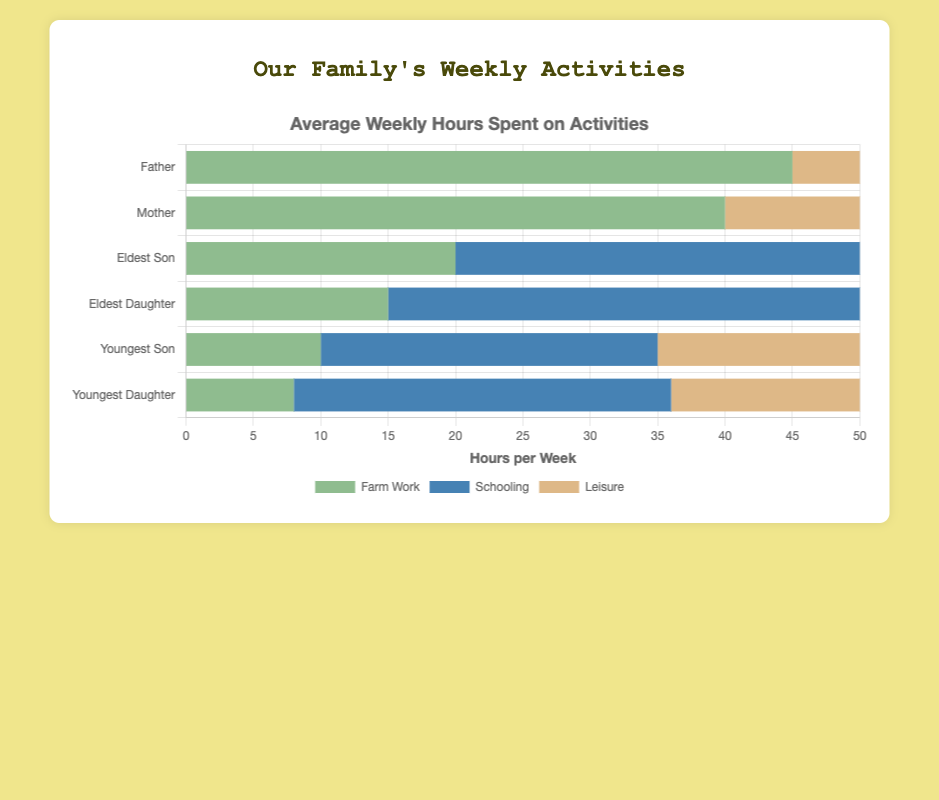What percentage of the father's weekly hours are spent on leisure? The total weekly hours for the father are 45 hours on farm work and 5 hours on leisure, making a total of 50 hours. The percentage spent on leisure is (5 / 50) * 100% = 10%.
Answer: 10% How many more hours does the mother spend on farm work than on leisure? The mother spends 40 hours on farm work and 10 hours on leisure. The difference is 40 - 10 = 30 hours.
Answer: 30 hours Who spends the most hours on schooling each week? By looking at the schooling hours for all family members, the eldest daughter spends the most hours at 35 hours per week.
Answer: Eldest Daughter What is the total number of hours the youngest son spends on farming and schooling combined? The youngest son spends 10 hours on farm work and 25 hours on schooling. Adding them together, the total is 10 + 25 = 35 hours.
Answer: 35 hours Compare the total hours spent on leisure by the eldest son and youngest daughter. Who spends more? The eldest son spends 18 hours on leisure, and the youngest daughter spends 26 hours. Hence, the youngest daughter spends more hours on leisure.
Answer: Youngest Daughter Which family member spends the least amount of time on farm work, and how many hours do they spend? Checking the farm work hours for all family members, the youngest daughter spends the least with 8 hours.
Answer: Youngest Daughter, 8 hours What is the difference in total weekly hours spent on all activities between the eldest son and the youngest daughter? The eldest son spends a total of 20 + 30 + 18 = 68 hours weekly, and the youngest daughter spends 8 + 28 + 26 = 62 hours. The difference is 68 - 62 = 6 hours.
Answer: 6 hours How do the average weekly farm work hours of the mother compare to the father? The father spends 45 hours on farm work while the mother spends 40 hours. The father spends 5 more hours on farm work than the mother.
Answer: Father spends 5 more hours What is the combined total weekly time spent by all family members on farm work? Adding up the farm work hours for all members: 45 (father) + 40 (mother) + 20 (eldest son) + 15 (eldest daughter) + 10 (youngest son) + 8 (youngest daughter) gives a total of 138 hours.
Answer: 138 hours What proportion of the eldest daughter's weekly hours is spent on schooling? The total weekly hours for the eldest daughter are 15 hours on farm work, 35 hours on schooling, and 18 hours on leisure, making 68 hours in total. The proportion spent on schooling is 35 / 68 ≈ 0.5147, which is approximately 51.47%.
Answer: ~51.47% 